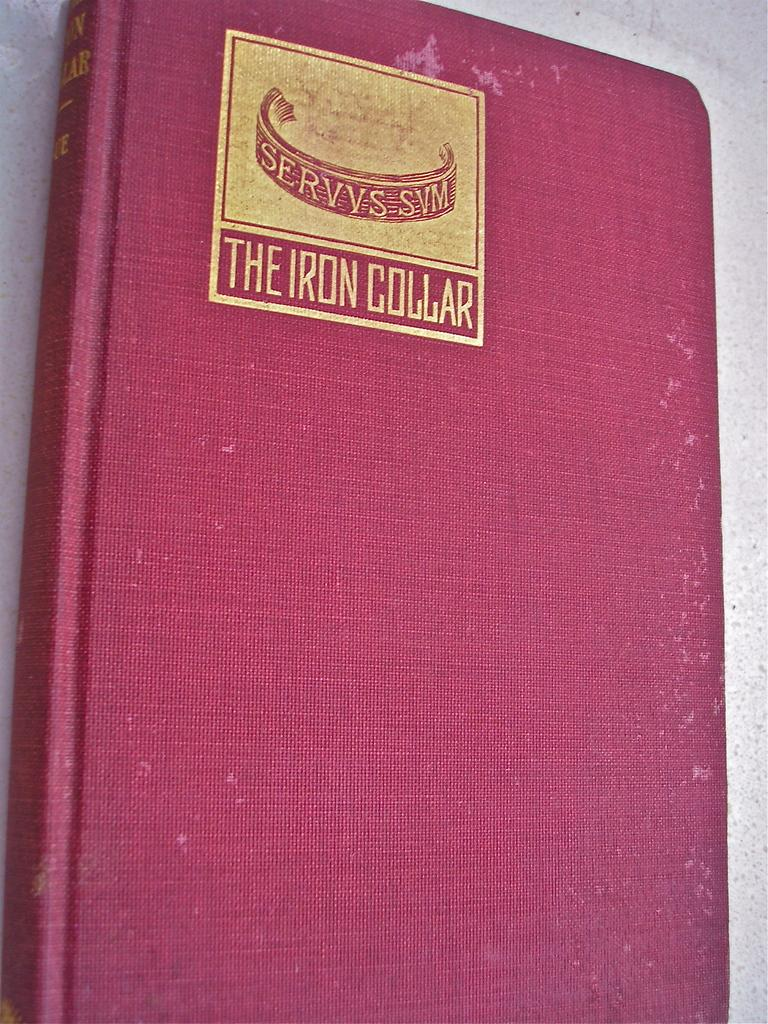<image>
Share a concise interpretation of the image provided. A red book has the title The Iron Collar in gold lettering. 